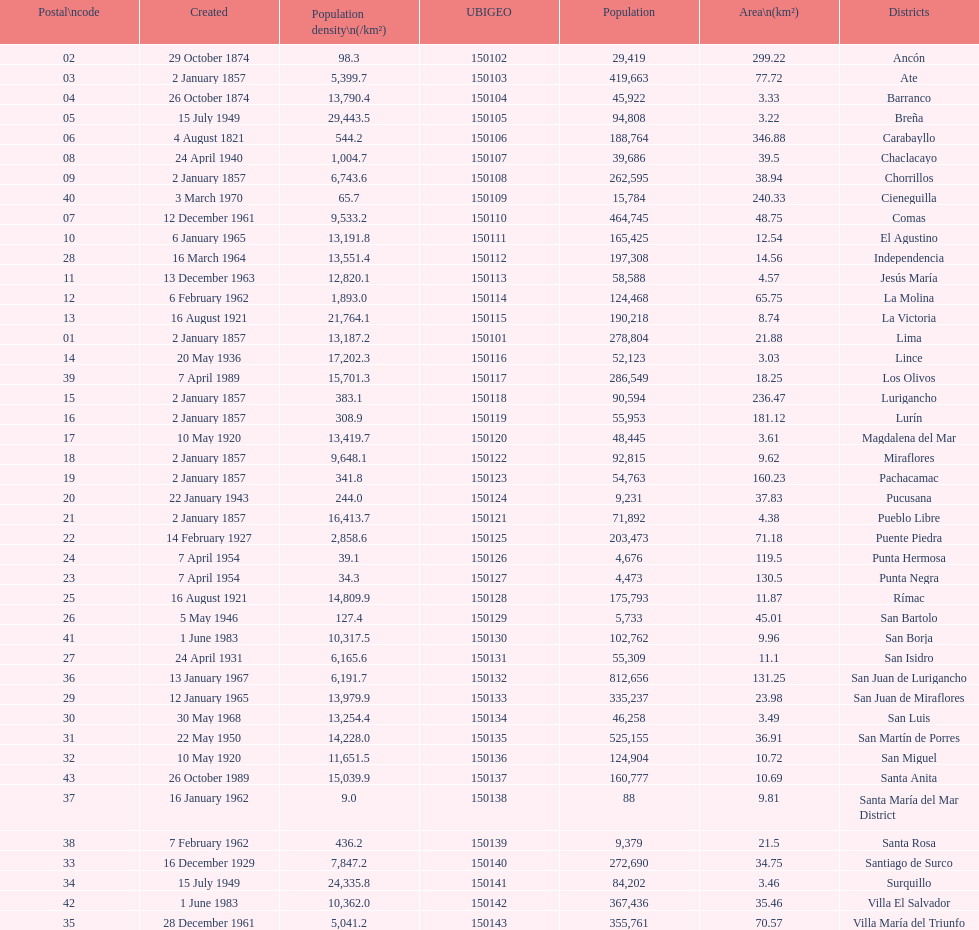Which is the largest district in terms of population? San Juan de Lurigancho. 